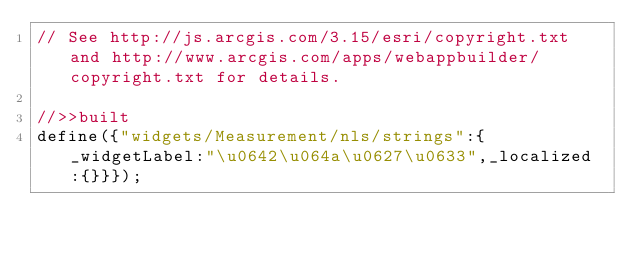Convert code to text. <code><loc_0><loc_0><loc_500><loc_500><_JavaScript_>// See http://js.arcgis.com/3.15/esri/copyright.txt and http://www.arcgis.com/apps/webappbuilder/copyright.txt for details.
//>>built
define({"widgets/Measurement/nls/strings":{_widgetLabel:"\u0642\u064a\u0627\u0633",_localized:{}}});</code> 